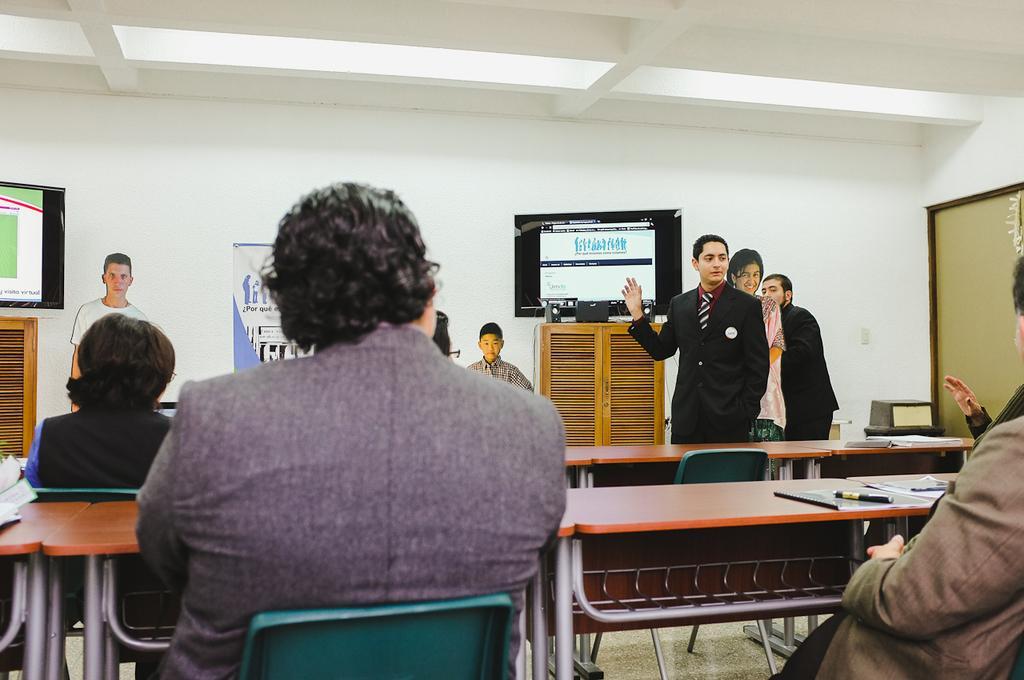In one or two sentences, can you explain what this image depicts? This is a wall. Here we can see aboard. We can see persons´s boards here,. This is a television. Here we can see a man standing and talking. We can see all the persons sitting on chairs in front of a table and on the table we can see books, pen. This is a floor. 